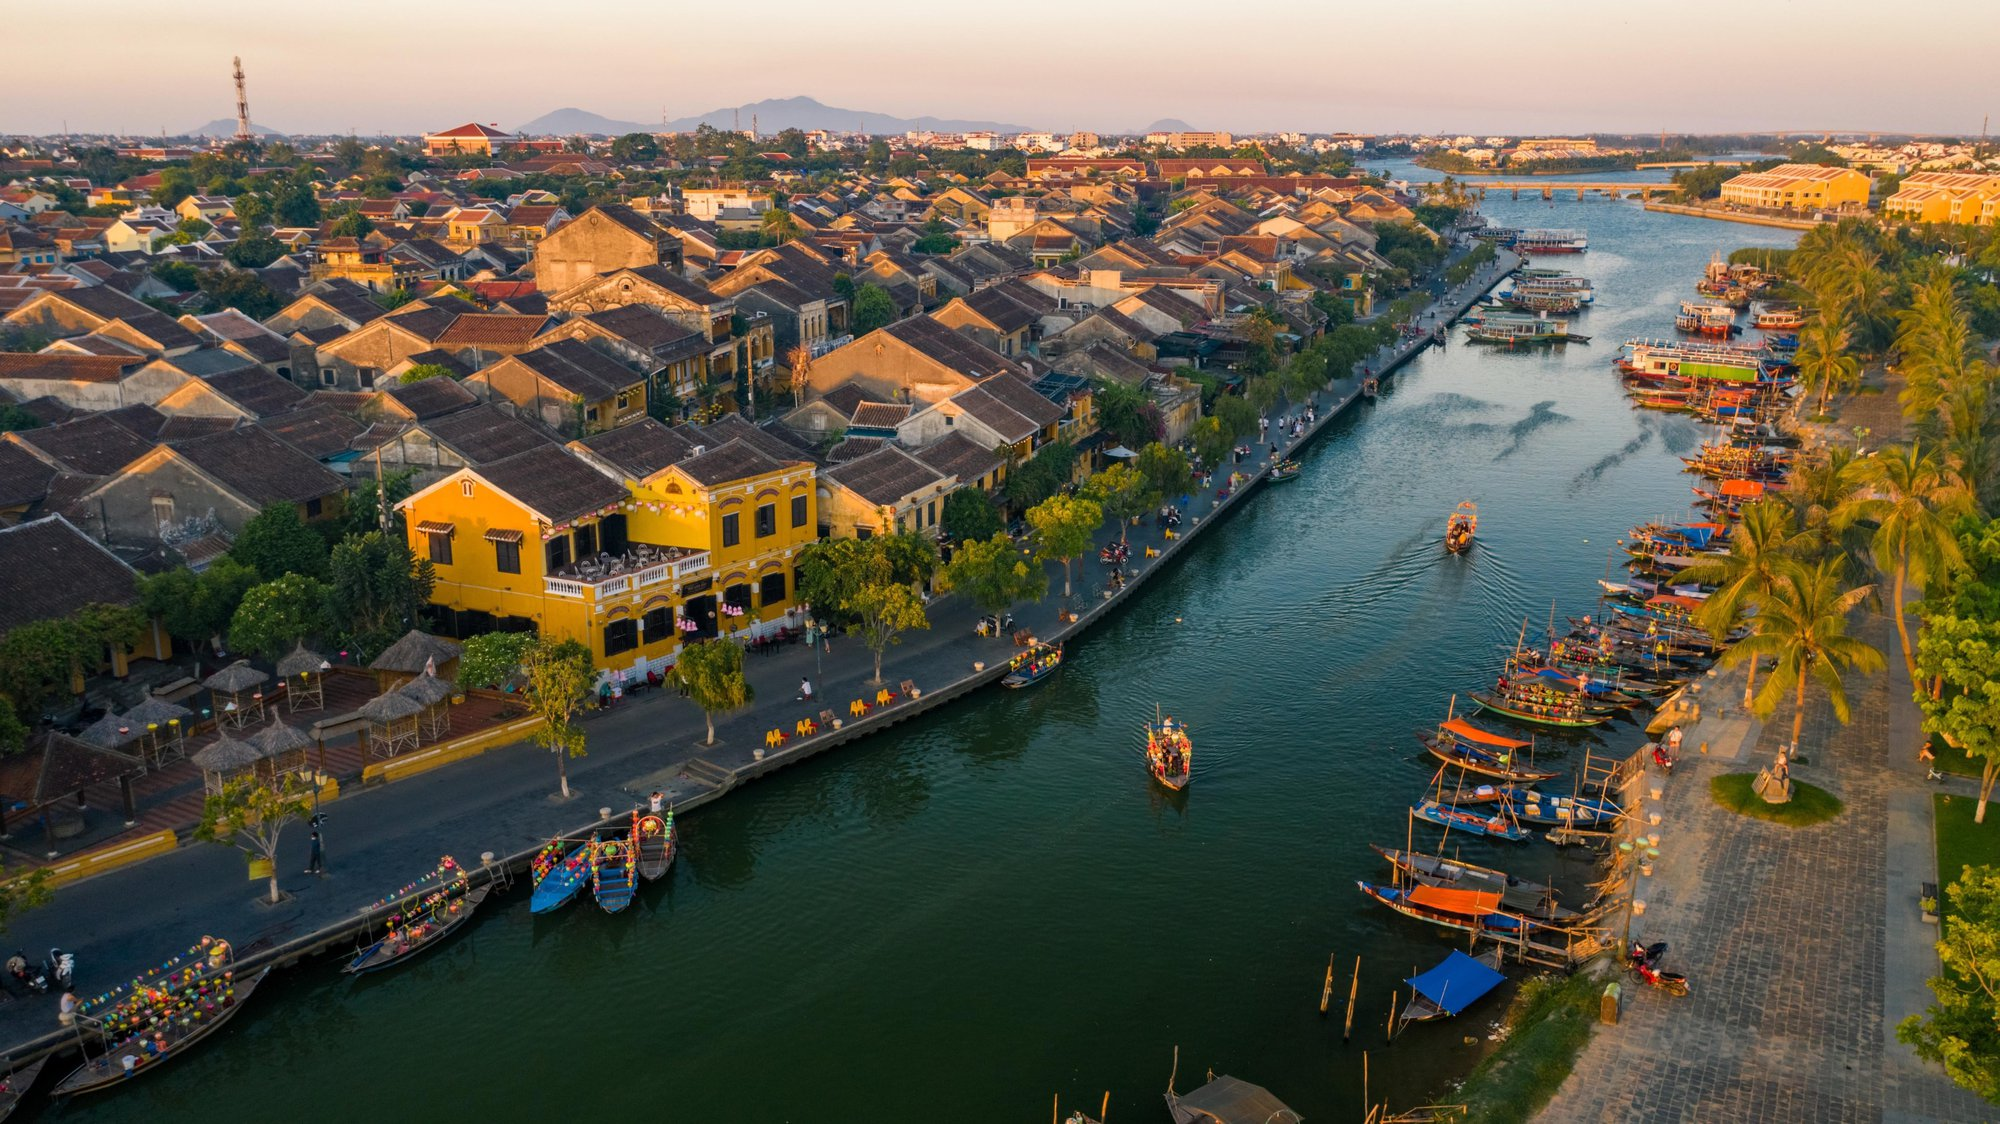Can you tell more about the architecture style seen in Hoi An in this image? Certainly! The architecture in Hoi An reflects a blend of indigenous and foreign influences, prominently seen through the yellow-painted facades and ornate wooden balconies. This style is an amalgamation of Vietnamese traditional design with Chinese and French colonial architectures, evident from the low, tiled roofs and narrow, wooden-front houses designed to suit the tropical climate while also accommodating commercial and residential needs. The use of vibrant colors and detailed woodwork on the balconies and windows adds to the aesthetic and functional aspects of these historical structures. 